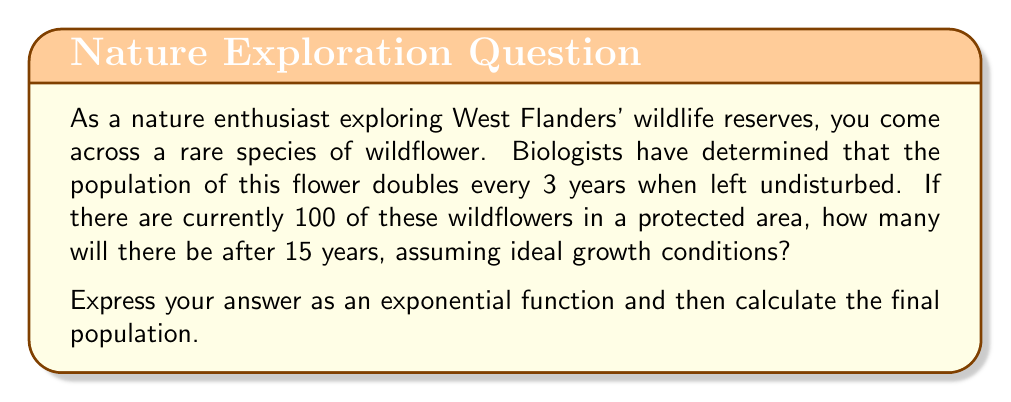Can you solve this math problem? Let's approach this step-by-step:

1) First, we need to identify the components of our exponential function:
   - Initial population: $P_0 = 100$
   - Growth rate: doubles every 3 years, so $r = 2$
   - Time: $t = 15$ years
   - Number of doubling periods: $15 \div 3 = 5$

2) The general form of an exponential growth function is:
   $$ P(t) = P_0 \cdot r^{t/k} $$
   Where $k$ is the time it takes for one doubling period.

3) In our case, this becomes:
   $$ P(15) = 100 \cdot 2^{15/3} $$

4) Simplify the exponent:
   $$ P(15) = 100 \cdot 2^5 $$

5) Calculate $2^5$:
   $$ 2^5 = 2 \times 2 \times 2 \times 2 \times 2 = 32 $$

6) Final calculation:
   $$ P(15) = 100 \cdot 32 = 3200 $$

Therefore, after 15 years, there will be 3200 wildflowers in the protected area.
Answer: The exponential function is $P(t) = 100 \cdot 2^{t/3}$, and the final population after 15 years is 3200 wildflowers. 